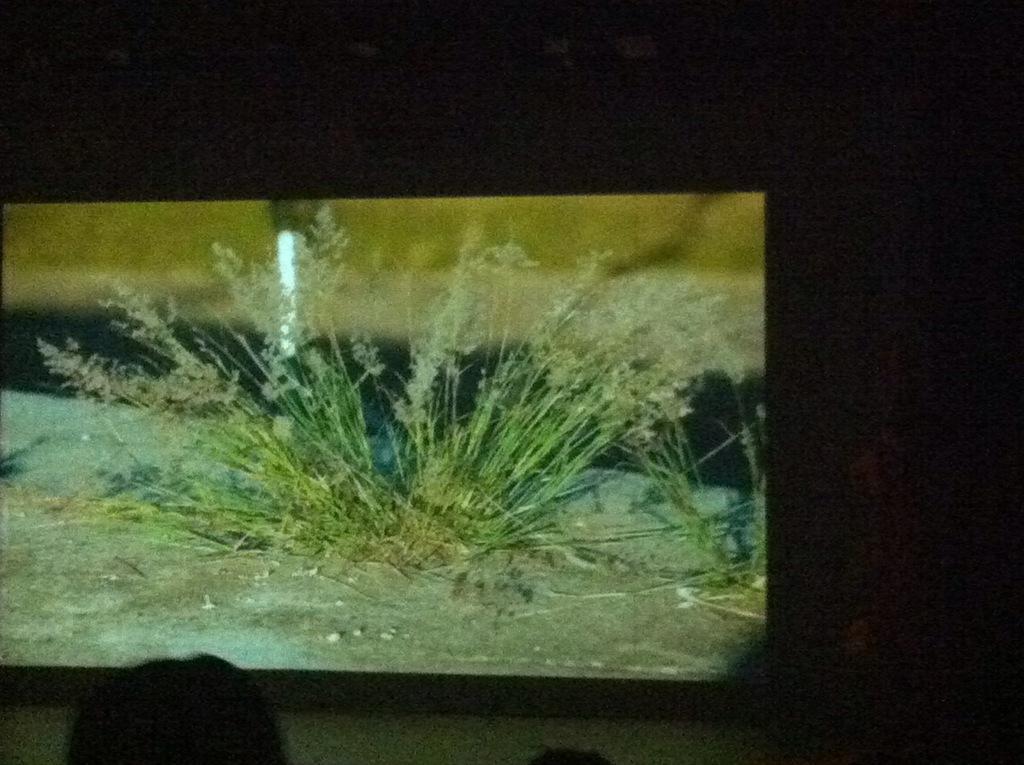Please provide a concise description of this image. The image of the grass is being displayed on the screen and the background of the screen is dark. 